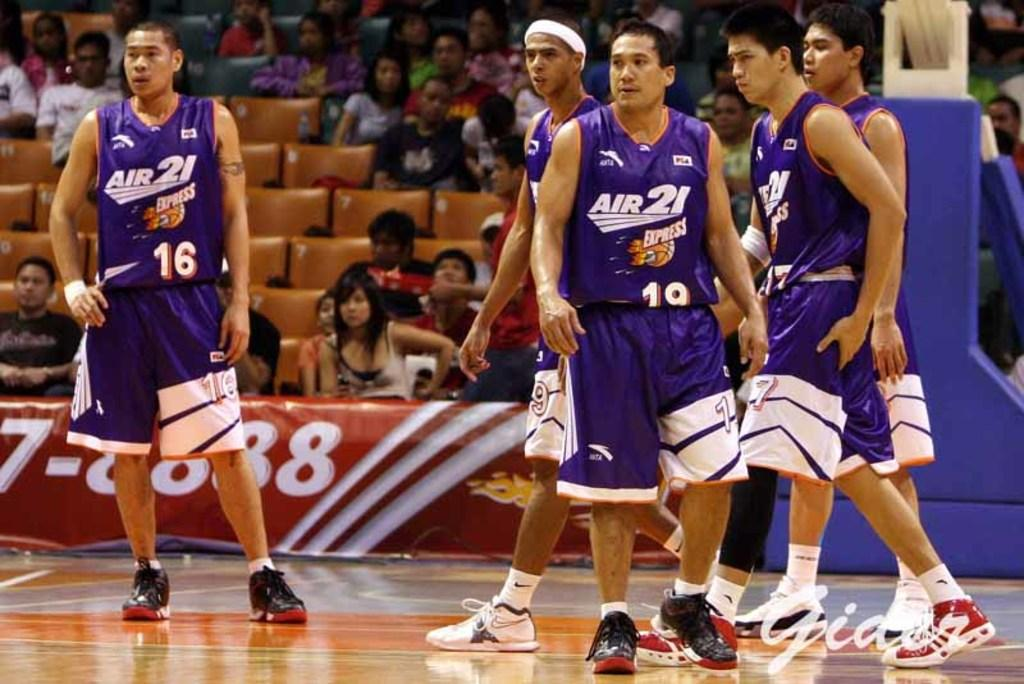<image>
Share a concise interpretation of the image provided. the name air is on one of the jerseys 